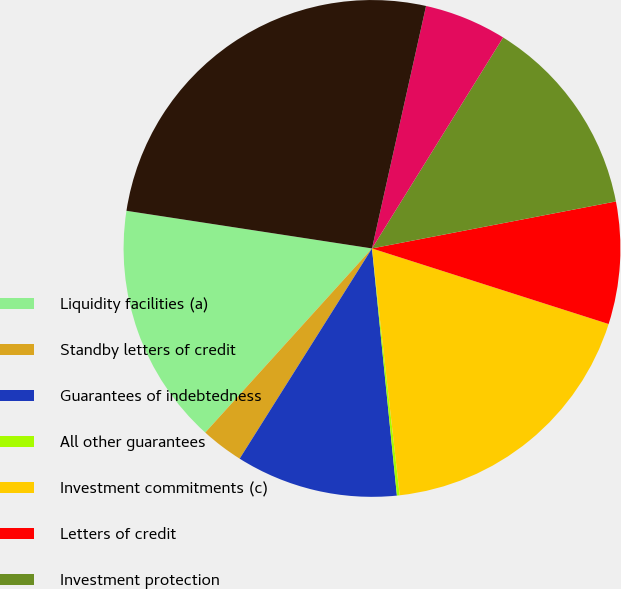Convert chart. <chart><loc_0><loc_0><loc_500><loc_500><pie_chart><fcel>Liquidity facilities (a)<fcel>Standby letters of credit<fcel>Guarantees of indebtedness<fcel>All other guarantees<fcel>Investment commitments (c)<fcel>Letters of credit<fcel>Investment protection<fcel>Other commercial commitments<fcel>Total (f)<nl><fcel>15.71%<fcel>2.77%<fcel>10.54%<fcel>0.18%<fcel>18.3%<fcel>7.95%<fcel>13.12%<fcel>5.36%<fcel>26.07%<nl></chart> 